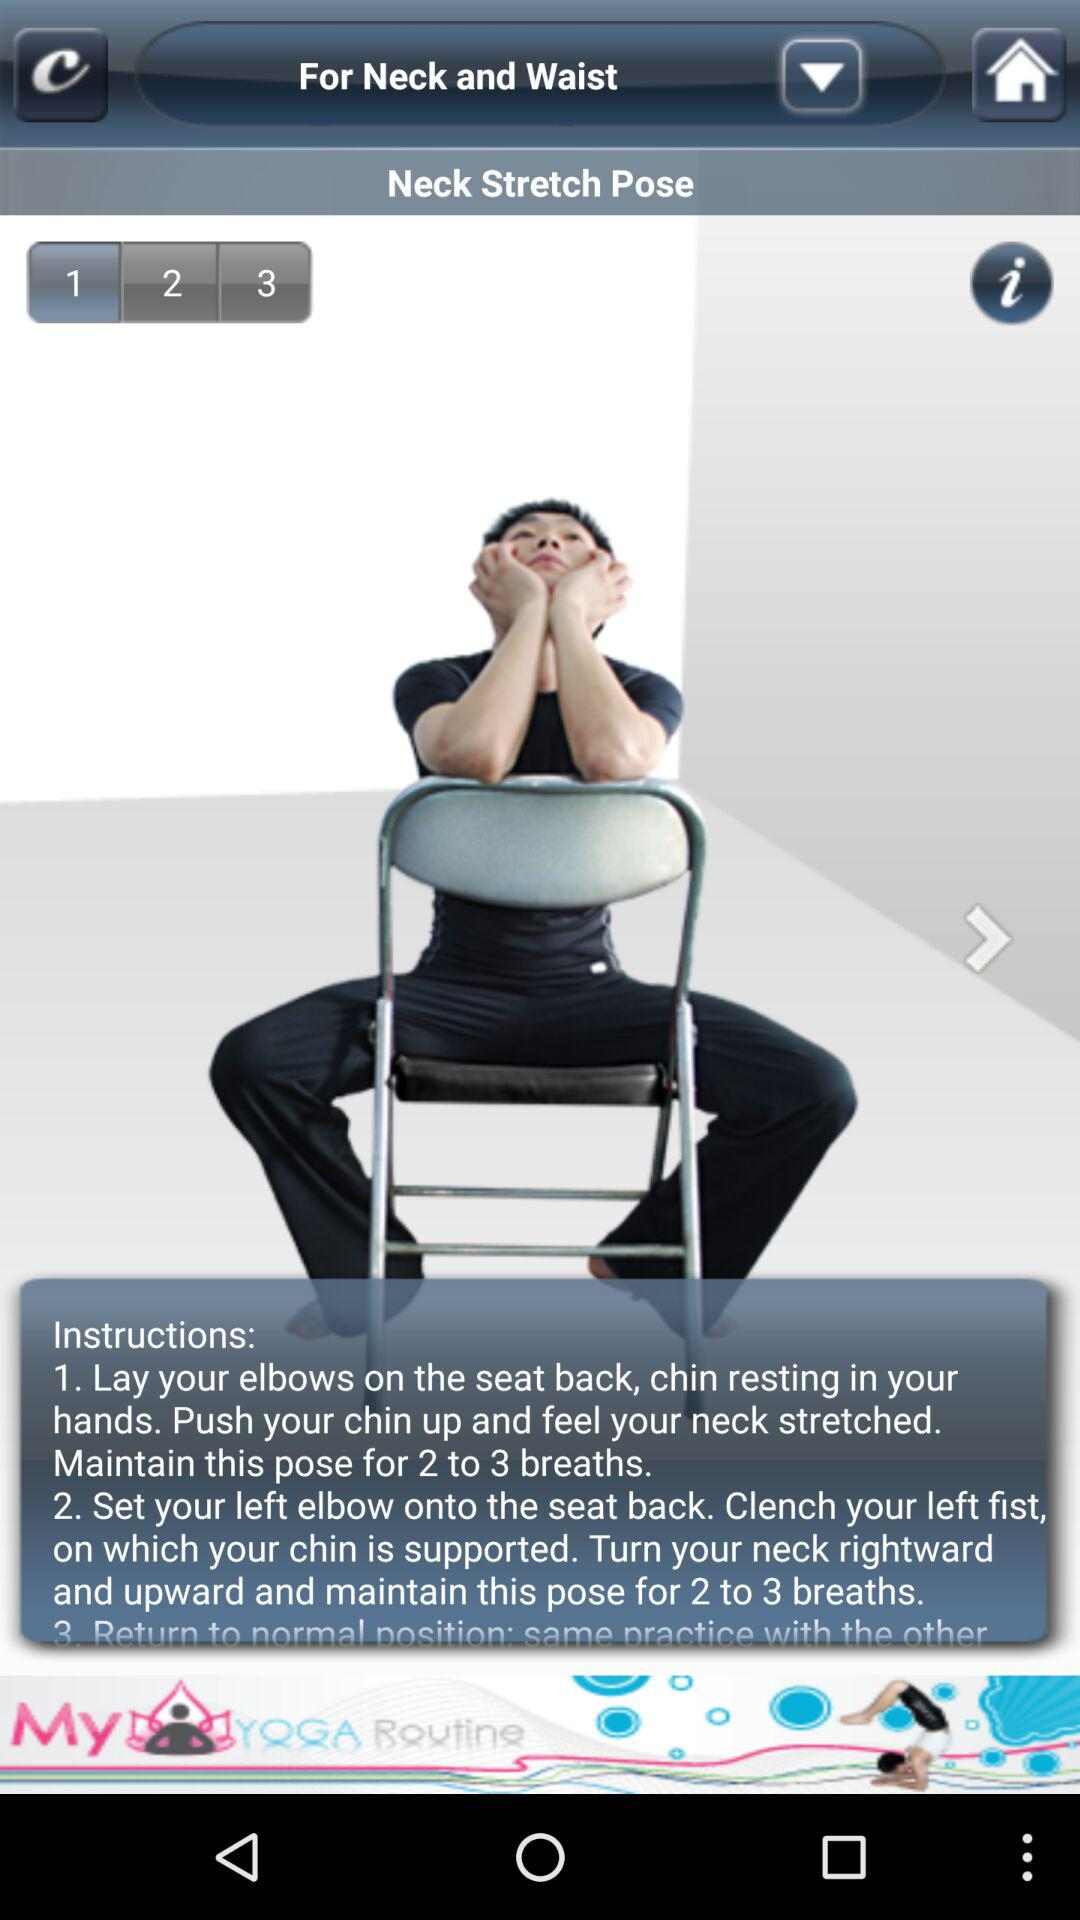How many instructions are there for the Neck Stretch Pose?
Answer the question using a single word or phrase. 3 